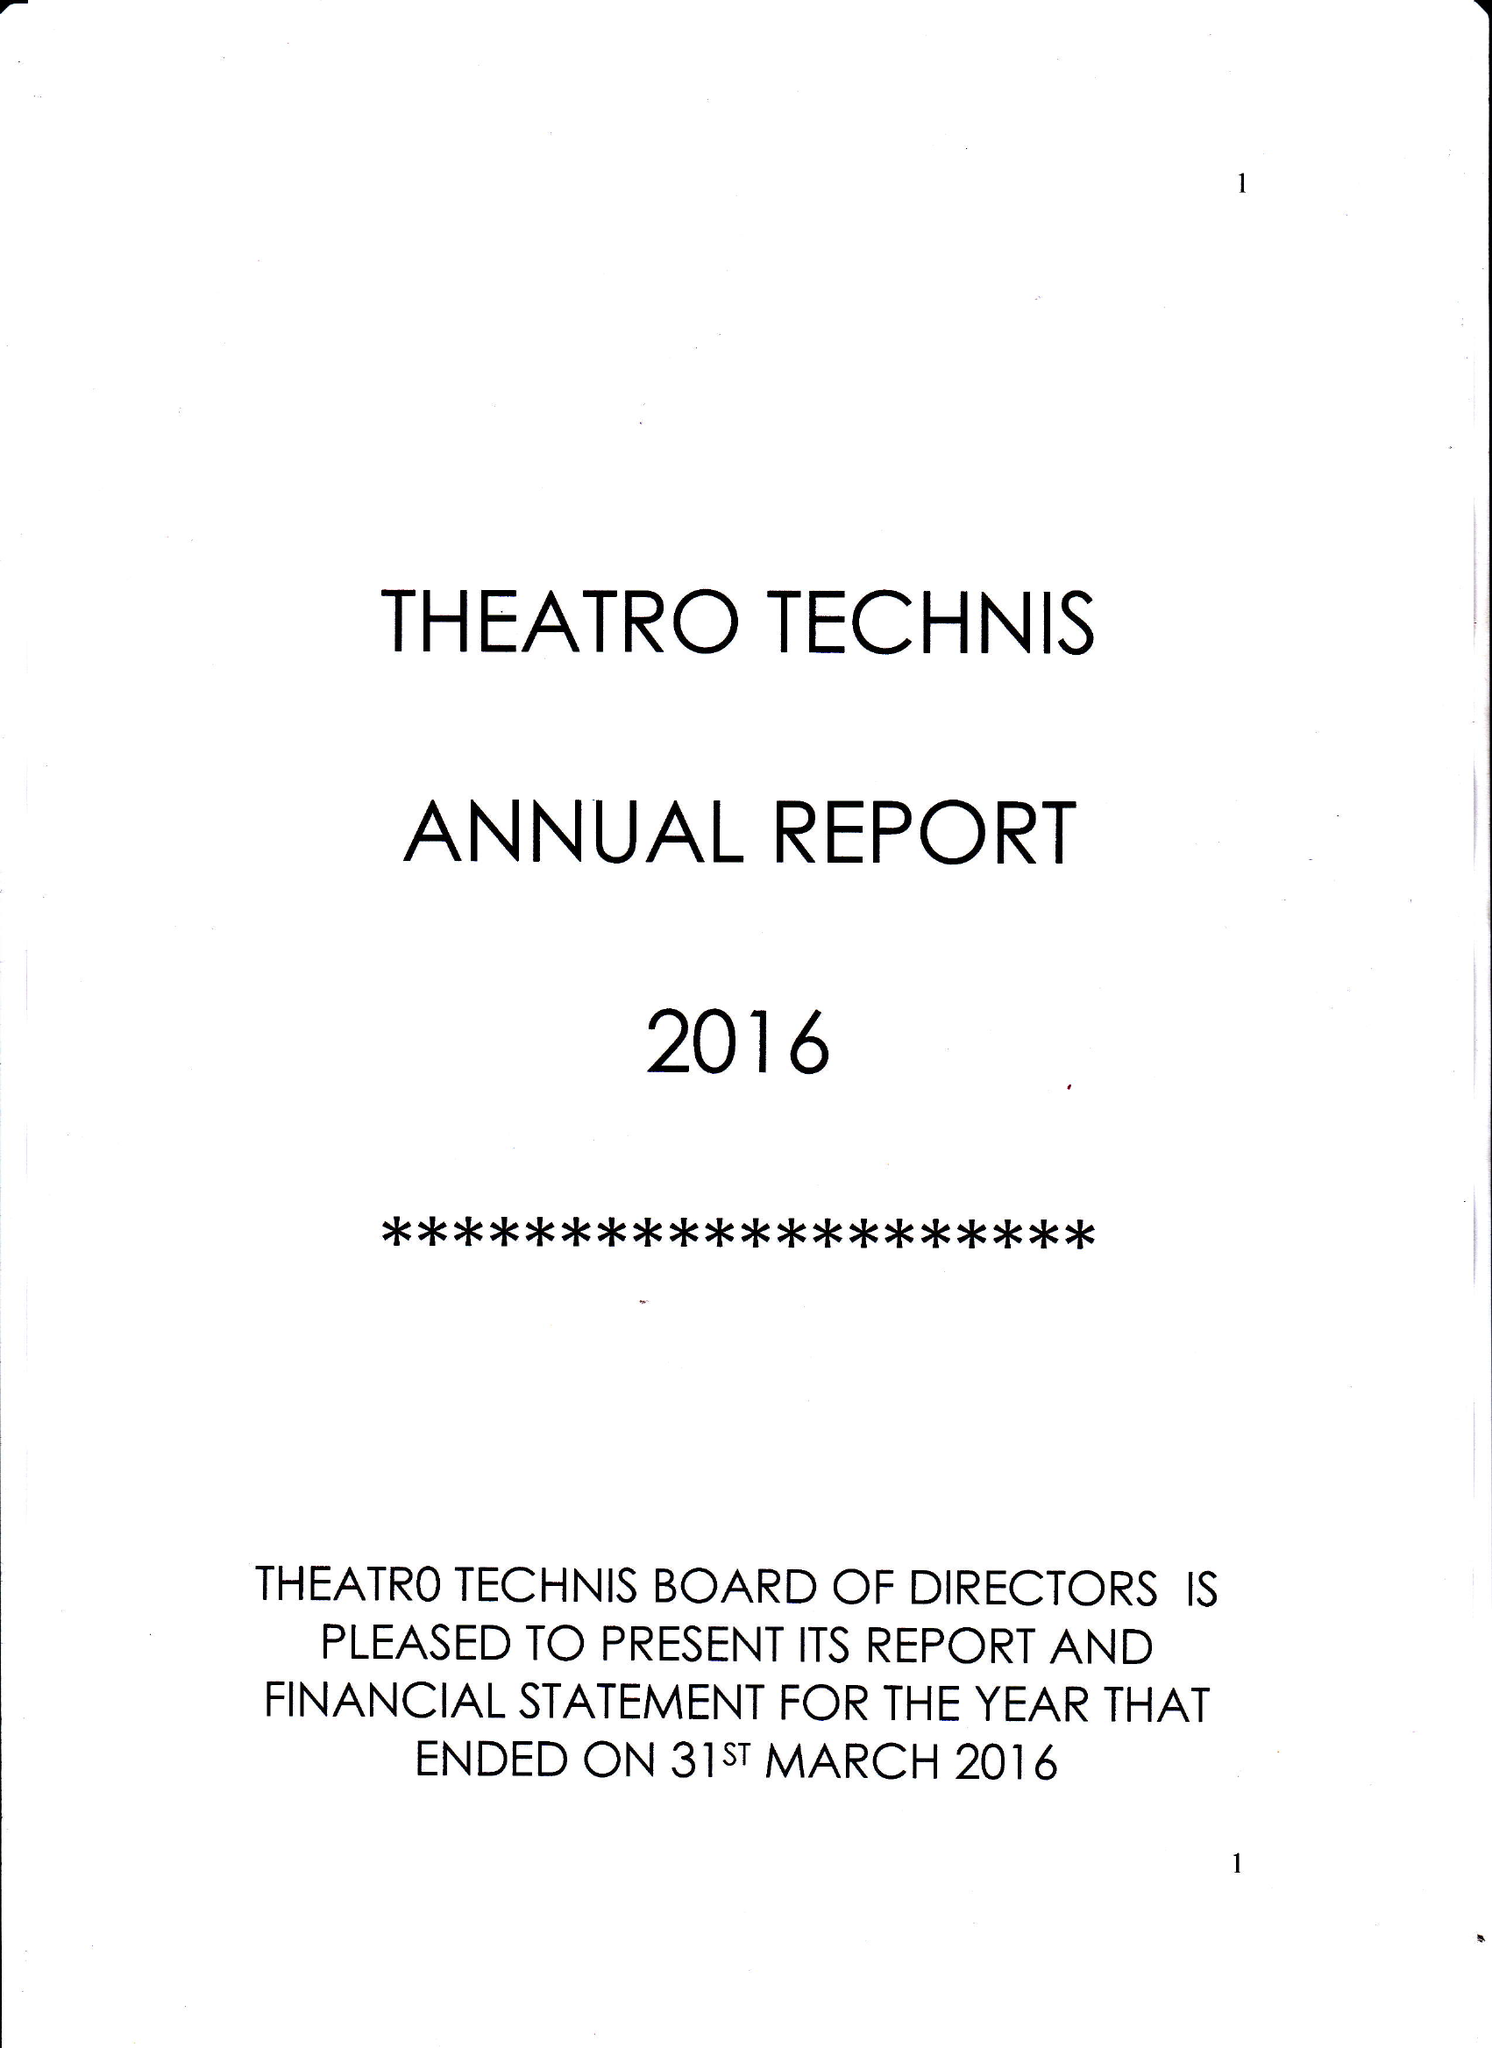What is the value for the report_date?
Answer the question using a single word or phrase. 2016-03-31 